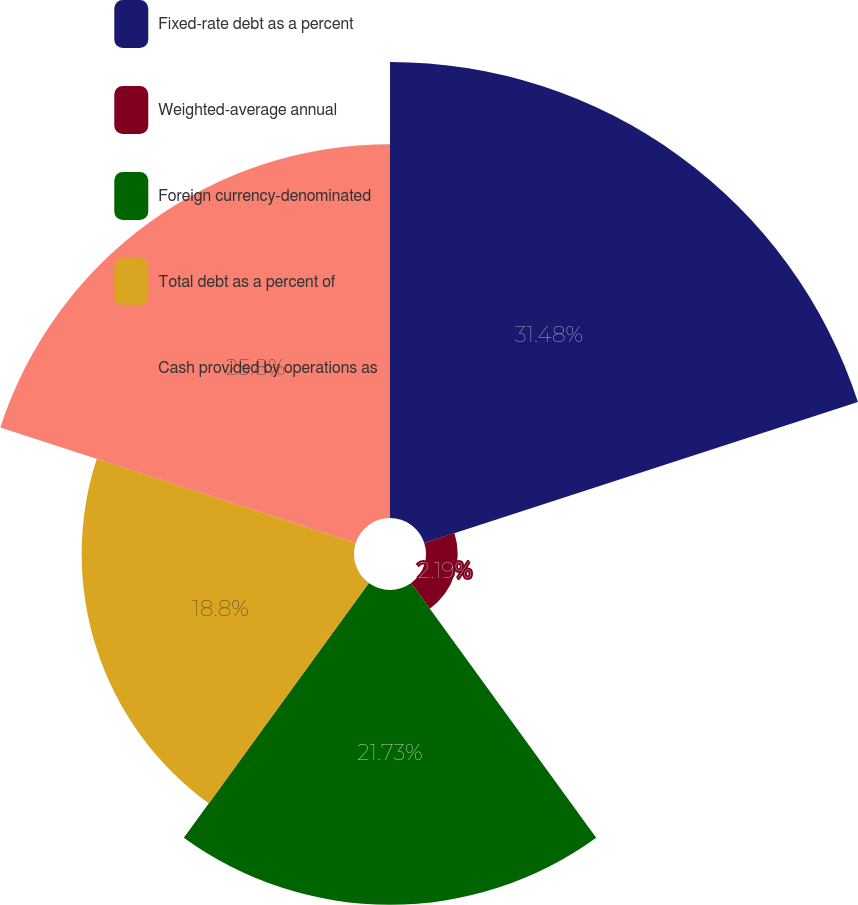Convert chart. <chart><loc_0><loc_0><loc_500><loc_500><pie_chart><fcel>Fixed-rate debt as a percent<fcel>Weighted-average annual<fcel>Foreign currency-denominated<fcel>Total debt as a percent of<fcel>Cash provided by operations as<nl><fcel>31.48%<fcel>2.19%<fcel>21.73%<fcel>18.8%<fcel>25.8%<nl></chart> 